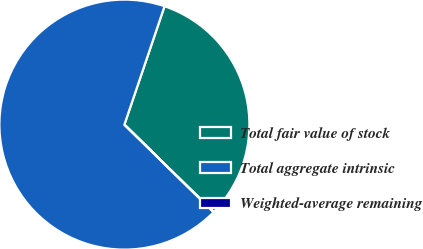<chart> <loc_0><loc_0><loc_500><loc_500><pie_chart><fcel>Total fair value of stock<fcel>Total aggregate intrinsic<fcel>Weighted-average remaining<nl><fcel>32.13%<fcel>67.86%<fcel>0.01%<nl></chart> 